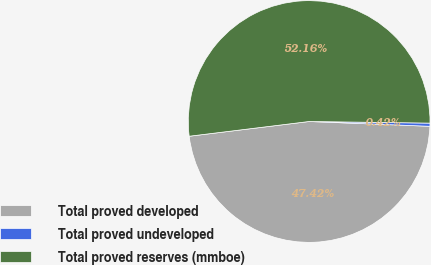Convert chart. <chart><loc_0><loc_0><loc_500><loc_500><pie_chart><fcel>Total proved developed<fcel>Total proved undeveloped<fcel>Total proved reserves (mmboe)<nl><fcel>47.42%<fcel>0.42%<fcel>52.16%<nl></chart> 